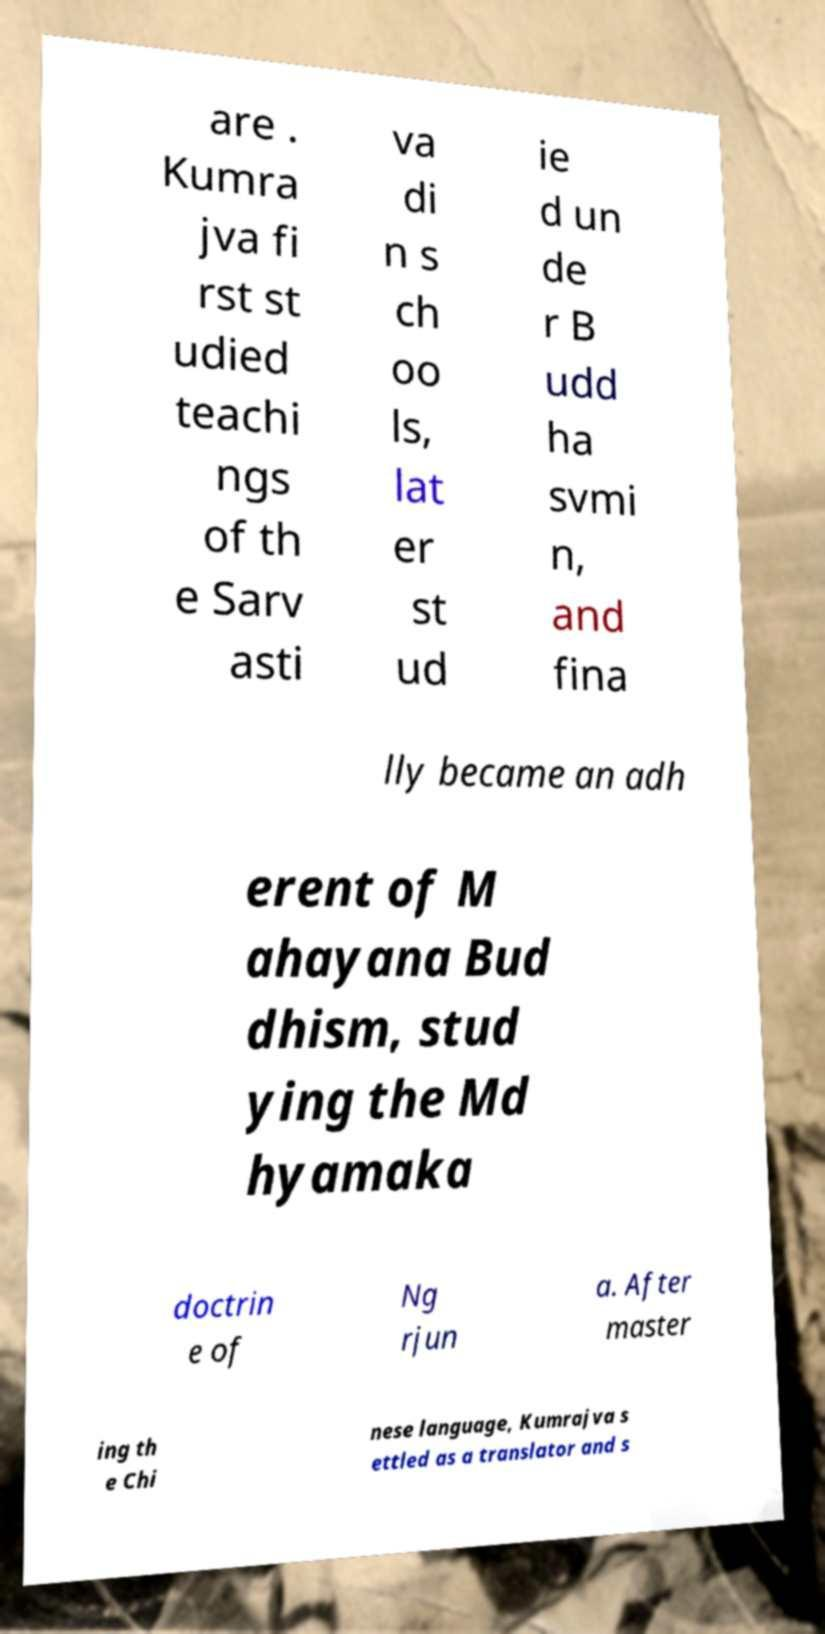Could you extract and type out the text from this image? are . Kumra jva fi rst st udied teachi ngs of th e Sarv asti va di n s ch oo ls, lat er st ud ie d un de r B udd ha svmi n, and fina lly became an adh erent of M ahayana Bud dhism, stud ying the Md hyamaka doctrin e of Ng rjun a. After master ing th e Chi nese language, Kumrajva s ettled as a translator and s 